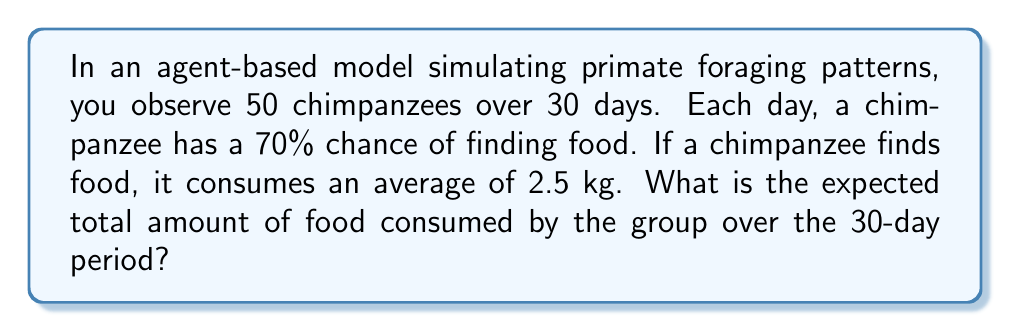What is the answer to this math problem? Let's break this down step-by-step:

1) First, we need to calculate the expected amount of food consumed by one chimpanzee in one day:

   $E(\text{food per chimp per day}) = P(\text{finding food}) \times \text{average amount consumed}$
   $E(\text{food per chimp per day}) = 0.70 \times 2.5 \text{ kg} = 1.75 \text{ kg}$

2) Now, we need to extend this to the entire group over the 30-day period:

   $E(\text{total food}) = E(\text{food per chimp per day}) \times \text{number of chimps} \times \text{number of days}$

3) Substituting the values:

   $E(\text{total food}) = 1.75 \text{ kg} \times 50 \times 30$

4) Calculating:

   $E(\text{total food}) = 1.75 \times 50 \times 30 = 2625 \text{ kg}$

Therefore, the expected total amount of food consumed by the group over the 30-day period is 2625 kg.
Answer: 2625 kg 